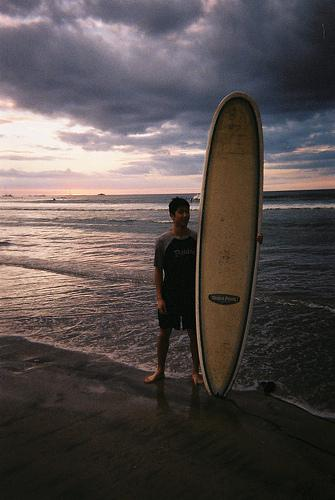Explain the reasoning behind the presence of sea foam on the water in this image. The presence of sea foam is likely due to the movement of the water and the waves crashing, which generates sea foam naturally. What type of sentiment or emotion does this image evoke? This image evokes a feeling of adventure, excitement, and freedom. Identify the object being held by the man and its color. A white surfboard is held by the man vertically. Mention the attributes of the clouds and their position in the image. The clouds are dark and located in the sky. Are there any features on the surfboard that can help identify its brand? Yes, there is a logo on the surfboard. Describe any interaction between the main subject and any other object in the image. The man is holding a surfboard vertically, implying that he is interacting with the surfboard. Provide a description of the water surface in the image. The surface of the ocean water features sea foam, light reflection, and white water from a crashed wave. What features can be observed about the boy present in the image? The boy is light-skinned, barefooted, wearing a tee shirt, and standing on beach sand. Count the number of people present in the image. There are two people in the image - a man and a boy. Analyzing the image, would you say the quality is high or low resolution? Based on the information provided, we cannot determine the image resolution. What objects can you find in the image? Man, surfboard, clouds, hand, leg, ocean water, wave, logo, sea foam, light reflection, beach sand. What is the boy wearing? A tee shirt. What color are the clouds? Dark. Describe the colorful beach ball lying on the beach sand near the boy's feet. The image information does not mention a beach ball, especially not with specific colors or its location near the boy's feet. Describe the surface of the water in the image. Ocean water with white water of crashed wave, sea foam, and light reflection. Can you locate the dog wearing a red collar next to the surfboard? There is no mention of a dog or a red collar in the provided information about objects in the image. What color is the surfboard? White. Notice the green umbrella next to the boy holding the surfboard. There is no mention of a green umbrella or any other umbrella in the provided information about objects in the image. What is written on the surfboard? Logo. Are there any clouds in the image? If so, describe them. Yes, there are dark clouds in the sky. Describe the scene in the image. A young man in a tee shirt is standing on a sandy beach holding a white surfboard vertically, with the logo visible. Dark clouds fill the sky and white water from a crashed wave, sea foam, and light reflection can be seen on the surface of the ocean water. What is the interaction between the man and the surfboard? The man is holding the surfboard vertically. List the characteristics of the boy. Light-skinned, barefoot, standing, wearing a tee shirt. Determine if any part of the image has poor quality based on provided information. No poor quality areas detected. Find the woman in a yellow dress sitting on a bench near the ocean. The image information does not mention a woman or a yellow dress, and there is no mention of a bench near the ocean. Identify the objects in the image and their positions. Man at (148, 196), surfboard at (196, 87), clouds at (69, 25), hand at (151, 265), leg at (145, 327), ocean water at (3, 190), wave at (265, 202), logo at (207, 291), sea foam at (66, 309), light reflection at (0, 227), beach sand at (8, 361). What type of questions can we answer based on the provided image information? Object Detection, Image Captioning, Sentiment Analysis, Quality Assessment, Interaction, Anomaly Detection, Referential Expression Grounding, Object Attribute Detection, Semantic Segmentation. Locate any anomalies within the image. No anomalies detected. Which object is being held vertically by the hand? Surfboard. How would you describe the overall atmosphere of the image? Active and potentially moody due to the dark clouds and ocean waves. Is the beach sand visible in the image? If yes, where is it located? Yes, it is located at (8, 361). Identify the pier extending into the ocean water in the background of the image. There is no mention of a pier, or any structure extending into the ocean in the provided information about objects in the image. What do you think about the seagulls flying above the dark clouds? There are no seagulls mentioned in the provided information about objects in the image, so there is no reference to birds or any flying creatures. What is the man's position in the image? X:148, Y:196. 